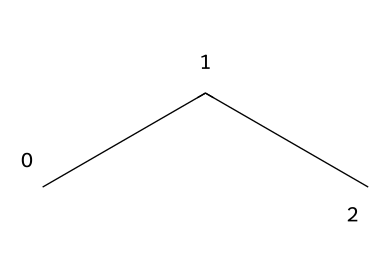What is the molecular formula of this refrigerant? The SMILES representation "CCC" indicates three carbon (C) atoms connected by single bonds, and for each carbon, there are sufficient hydrogen (H) atoms to satisfy carbon's tetravalency. The molecular formula is C3H8.
Answer: C3H8 How many total hydrogen atoms are in this chemical? Each carbon in propane has sufficient hydrogen atoms to reach four bonds. With three carbon atoms, there are a total of eight hydrogen atoms, as indicated by the molecular formula C3H8.
Answer: 8 Is this refrigerant a hydrocarbon? The structure "CCC" consists entirely of carbon and hydrogen atoms, which classifies it as a hydrocarbon.
Answer: Yes Does this refrigerant have any double bonds? The structure "CCC" is composed entirely of single bonds between the carbon atoms, which means there are no double bonds present in this refrigerant.
Answer: No What is the common use of R-290? R-290, or propane, is commonly used as an eco-friendly refrigerant in small-scale cooling systems such as refrigerators and air conditioners due to its low environmental impact.
Answer: Refrigeration What characteristic of R-290 makes it a suitable refrigerant? The main characteristic that makes R-290 suitable as a refrigerant is its low Global Warming Potential (GWP) combined with efficient thermodynamic properties for heat exchange, which allows it to effectively cool while being eco-friendly.
Answer: Low GWP What type of refrigerant is R-290 classified as? R-290 is classified as a natural refrigerant, which indicates it is derived from natural sources and has lower environmental impacts compared to synthetic refrigerants.
Answer: Natural 